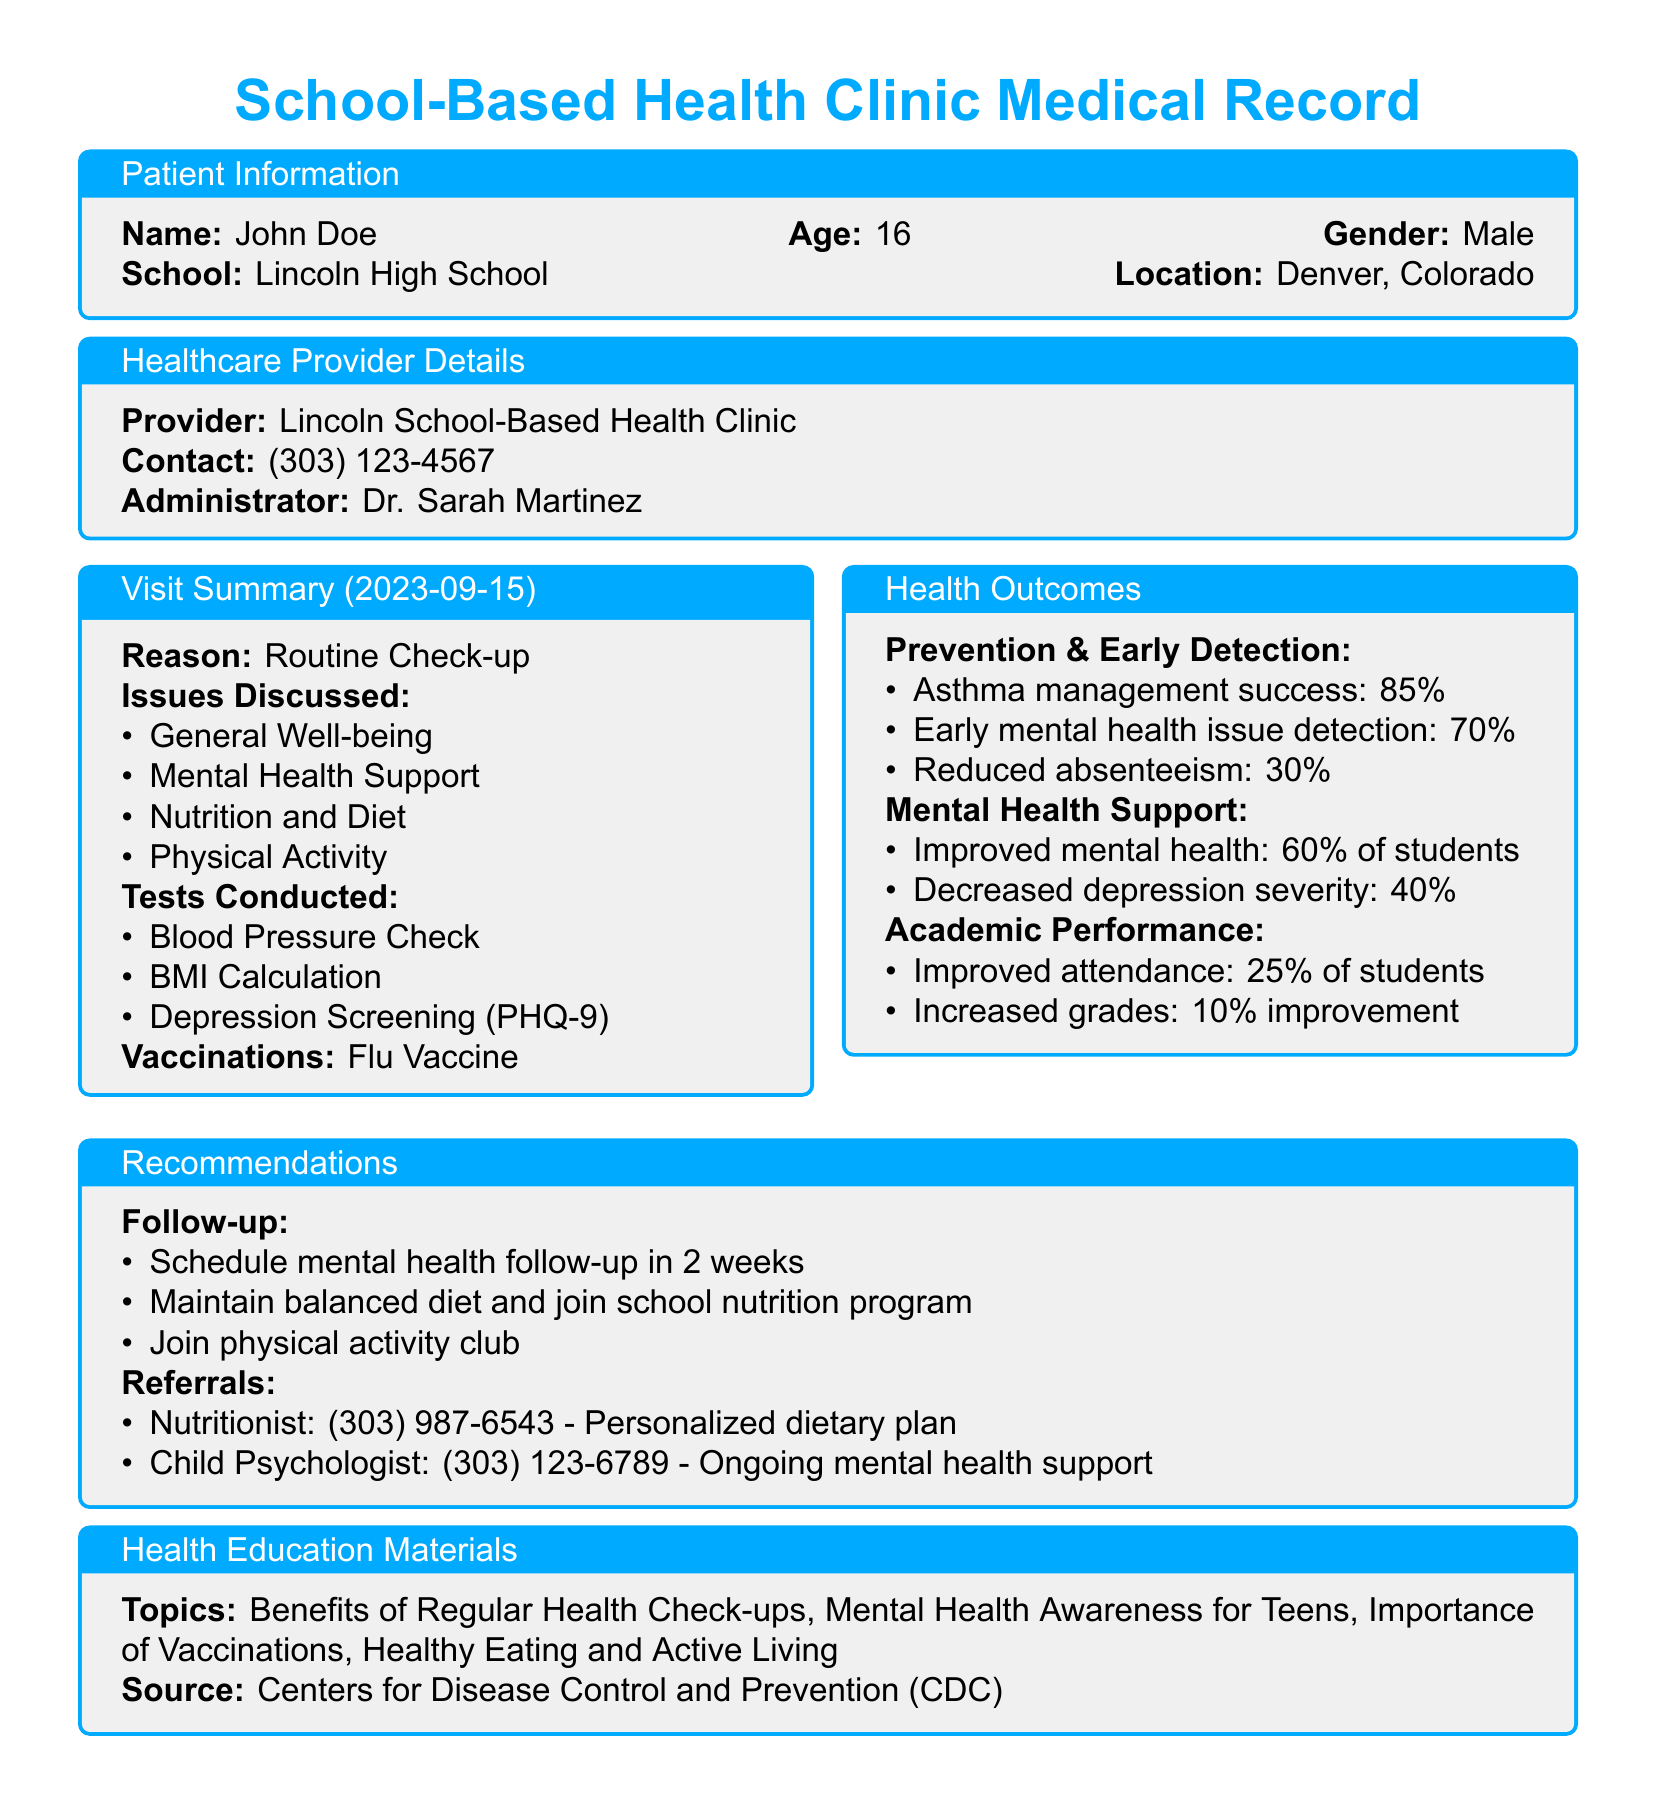What is the patient's name? The patient's name is listed in the Patient Information section of the document.
Answer: John Doe What is the age of the patient? The age of the patient is provided in the Patient Information section.
Answer: 16 What clinic did the patient visit? The healthcare provider's information includes the specific clinic that the patient visited.
Answer: Lincoln School-Based Health Clinic What issues were discussed during the visit? The visit summary includes a list of issues that were discussed with the healthcare provider.
Answer: General Well-being, Mental Health Support, Nutrition and Diet, Physical Activity What percentage of students improved their mental health? The Health Outcomes section provides data on mental health support and outcomes among students.
Answer: 60% What is the recommendation for follow-up? The Recommendations section indicates a specific follow-up action mentioned in the document.
Answer: Schedule mental health follow-up in 2 weeks How many students showed improved attendance? The academic performance outcomes in the document indicate the percentage of students with improved attendance.
Answer: 25% What test was conducted for depression screening? The Tests Conducted section of the visit summary specifies the method used for depression screening.
Answer: PHQ-9 What percentage of students had early detection of mental health issues? The Health Outcomes section indicates the success rate for early detection of mental health issues.
Answer: 70% 